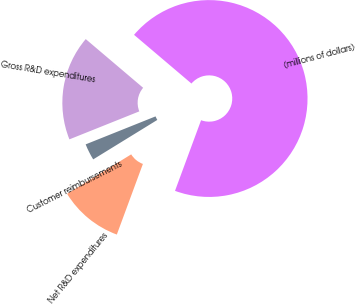Convert chart to OTSL. <chart><loc_0><loc_0><loc_500><loc_500><pie_chart><fcel>(millions of dollars)<fcel>Gross R&D expenditures<fcel>Customer reimbursements<fcel>Net R&D expenditures<nl><fcel>69.43%<fcel>17.26%<fcel>2.72%<fcel>10.59%<nl></chart> 